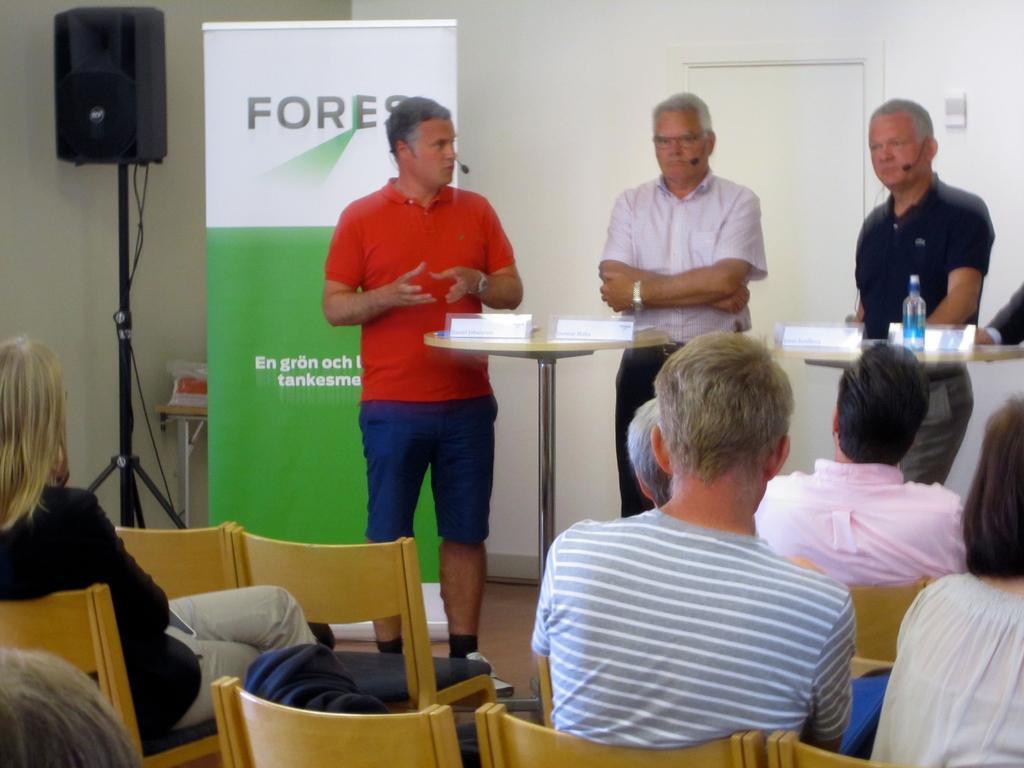In one or two sentences, can you explain what this image depicts? In the picture I can see people among them some are standing and some are sitting on chairs. In the background I can see a door, a wall, a sound speaker, a banner and some other objects. I can also see tables which has some objects on them. 